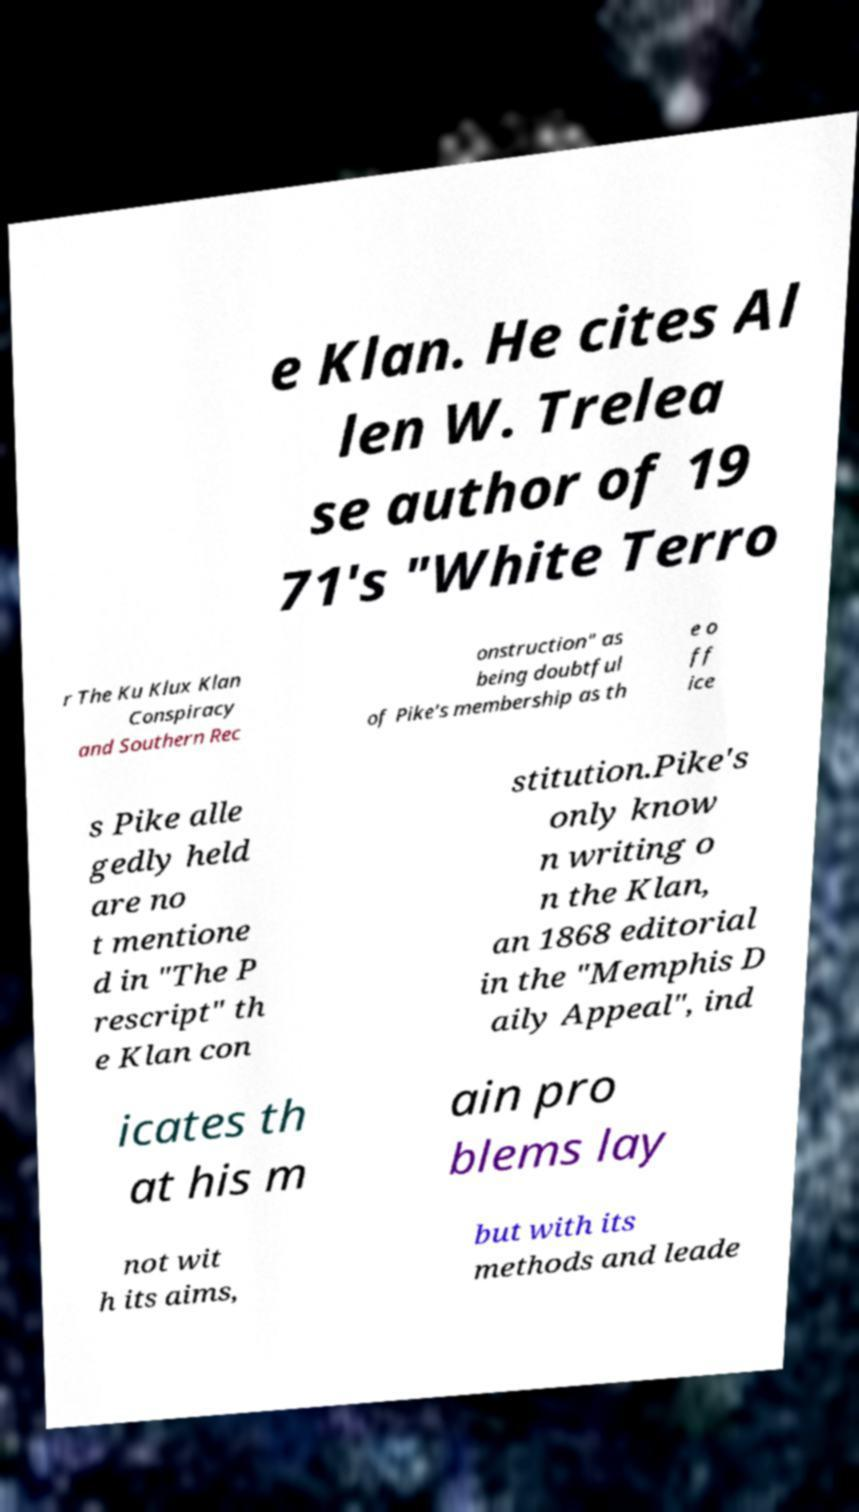Can you accurately transcribe the text from the provided image for me? e Klan. He cites Al len W. Trelea se author of 19 71's "White Terro r The Ku Klux Klan Conspiracy and Southern Rec onstruction" as being doubtful of Pike's membership as th e o ff ice s Pike alle gedly held are no t mentione d in "The P rescript" th e Klan con stitution.Pike's only know n writing o n the Klan, an 1868 editorial in the "Memphis D aily Appeal", ind icates th at his m ain pro blems lay not wit h its aims, but with its methods and leade 